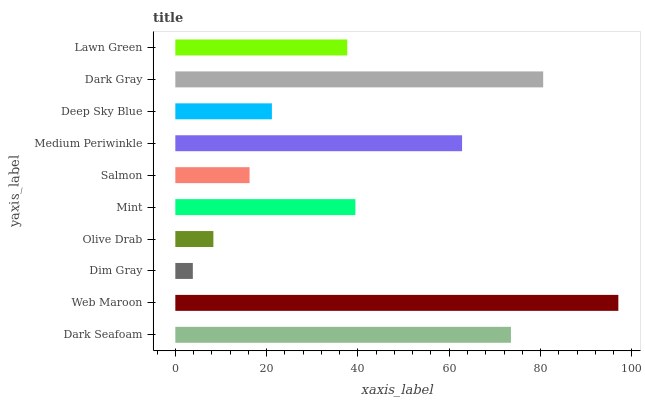Is Dim Gray the minimum?
Answer yes or no. Yes. Is Web Maroon the maximum?
Answer yes or no. Yes. Is Web Maroon the minimum?
Answer yes or no. No. Is Dim Gray the maximum?
Answer yes or no. No. Is Web Maroon greater than Dim Gray?
Answer yes or no. Yes. Is Dim Gray less than Web Maroon?
Answer yes or no. Yes. Is Dim Gray greater than Web Maroon?
Answer yes or no. No. Is Web Maroon less than Dim Gray?
Answer yes or no. No. Is Mint the high median?
Answer yes or no. Yes. Is Lawn Green the low median?
Answer yes or no. Yes. Is Dim Gray the high median?
Answer yes or no. No. Is Olive Drab the low median?
Answer yes or no. No. 